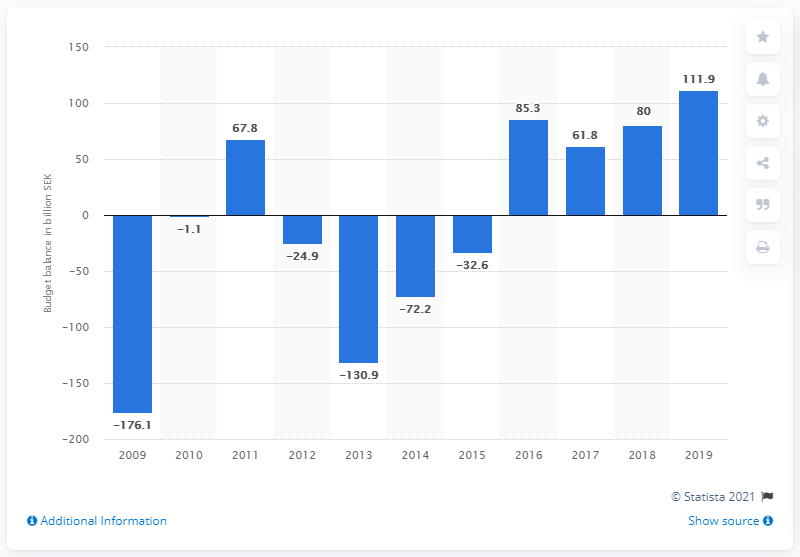Highlight a few significant elements in this photo. In 2019, the budget balance was 111.9. 